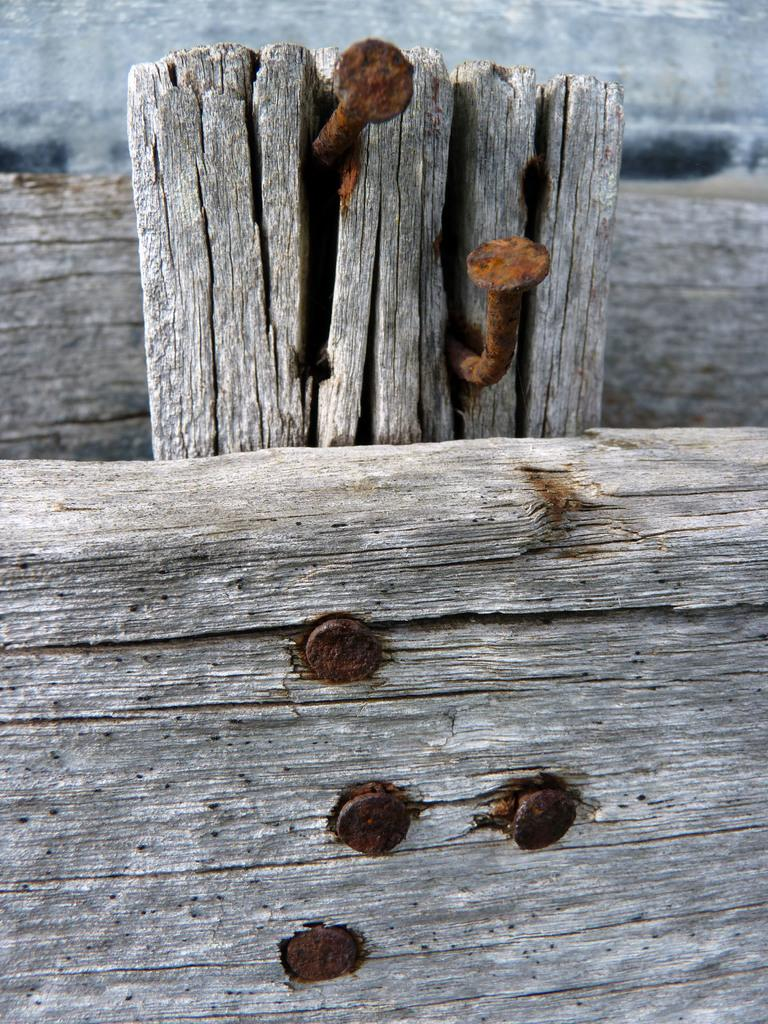What is the main object in the center of the image? There is a bamboo in the center of the image. What can be seen at the bottom side of the image? There are nails at the bottom side of the image. What time is displayed on the hourglass in the image? There is no hourglass present in the image; it only features bamboo and nails. How many dogs can be seen playing with the bamboo in the image? There are no dogs present in the image; it only features bamboo and nails. 